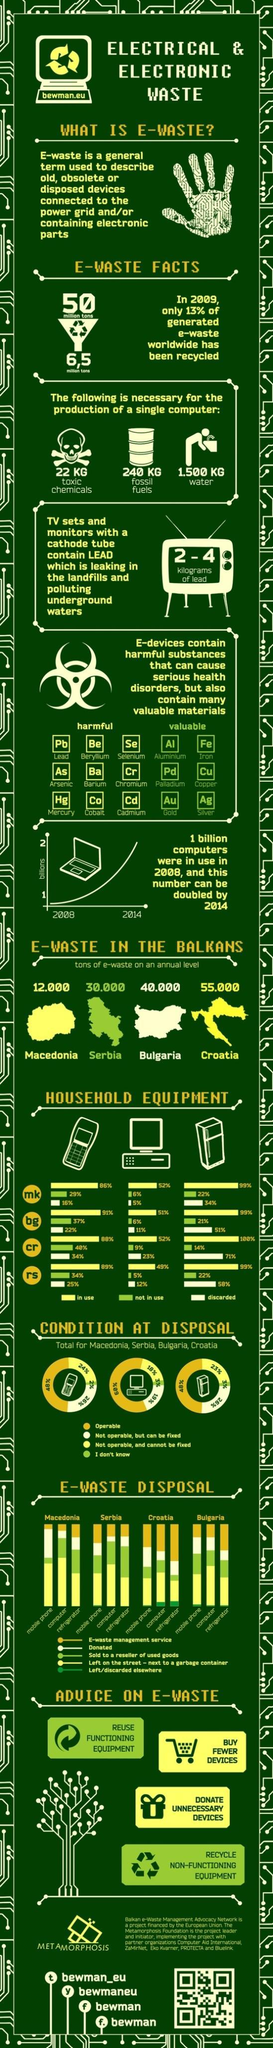What is the number of valuable substances mentioned in this infographic present in E-devices?
Answer the question with a short phrase. 6 What is the number of harmful substances mentioned in this infographic present in E-devices? 9 What is the percentage of operable mobiles? 48% What is the amount of E-waste in Croatia? 55.000 What is the amount of E-waste in Serbia? 30.000 What is the amount of toxic chemicals needed for the production of a single computer? 22 kg What is the amount of fossil fuel needed for the production of a single computer? 240 kg What is the amount of E-waste in Bulgaria? 40.000 What is the amount of E-waste in Macedonia? 12.000 What is the amount of water needed for the production of a single computer? 1.500 kg 